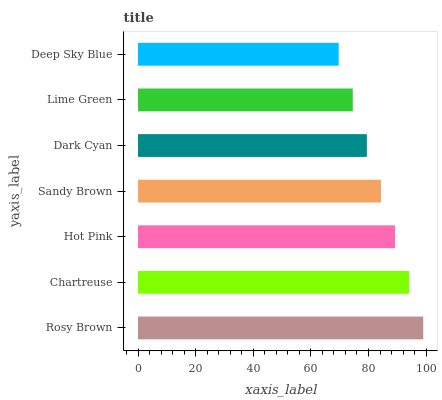Is Deep Sky Blue the minimum?
Answer yes or no. Yes. Is Rosy Brown the maximum?
Answer yes or no. Yes. Is Chartreuse the minimum?
Answer yes or no. No. Is Chartreuse the maximum?
Answer yes or no. No. Is Rosy Brown greater than Chartreuse?
Answer yes or no. Yes. Is Chartreuse less than Rosy Brown?
Answer yes or no. Yes. Is Chartreuse greater than Rosy Brown?
Answer yes or no. No. Is Rosy Brown less than Chartreuse?
Answer yes or no. No. Is Sandy Brown the high median?
Answer yes or no. Yes. Is Sandy Brown the low median?
Answer yes or no. Yes. Is Hot Pink the high median?
Answer yes or no. No. Is Hot Pink the low median?
Answer yes or no. No. 